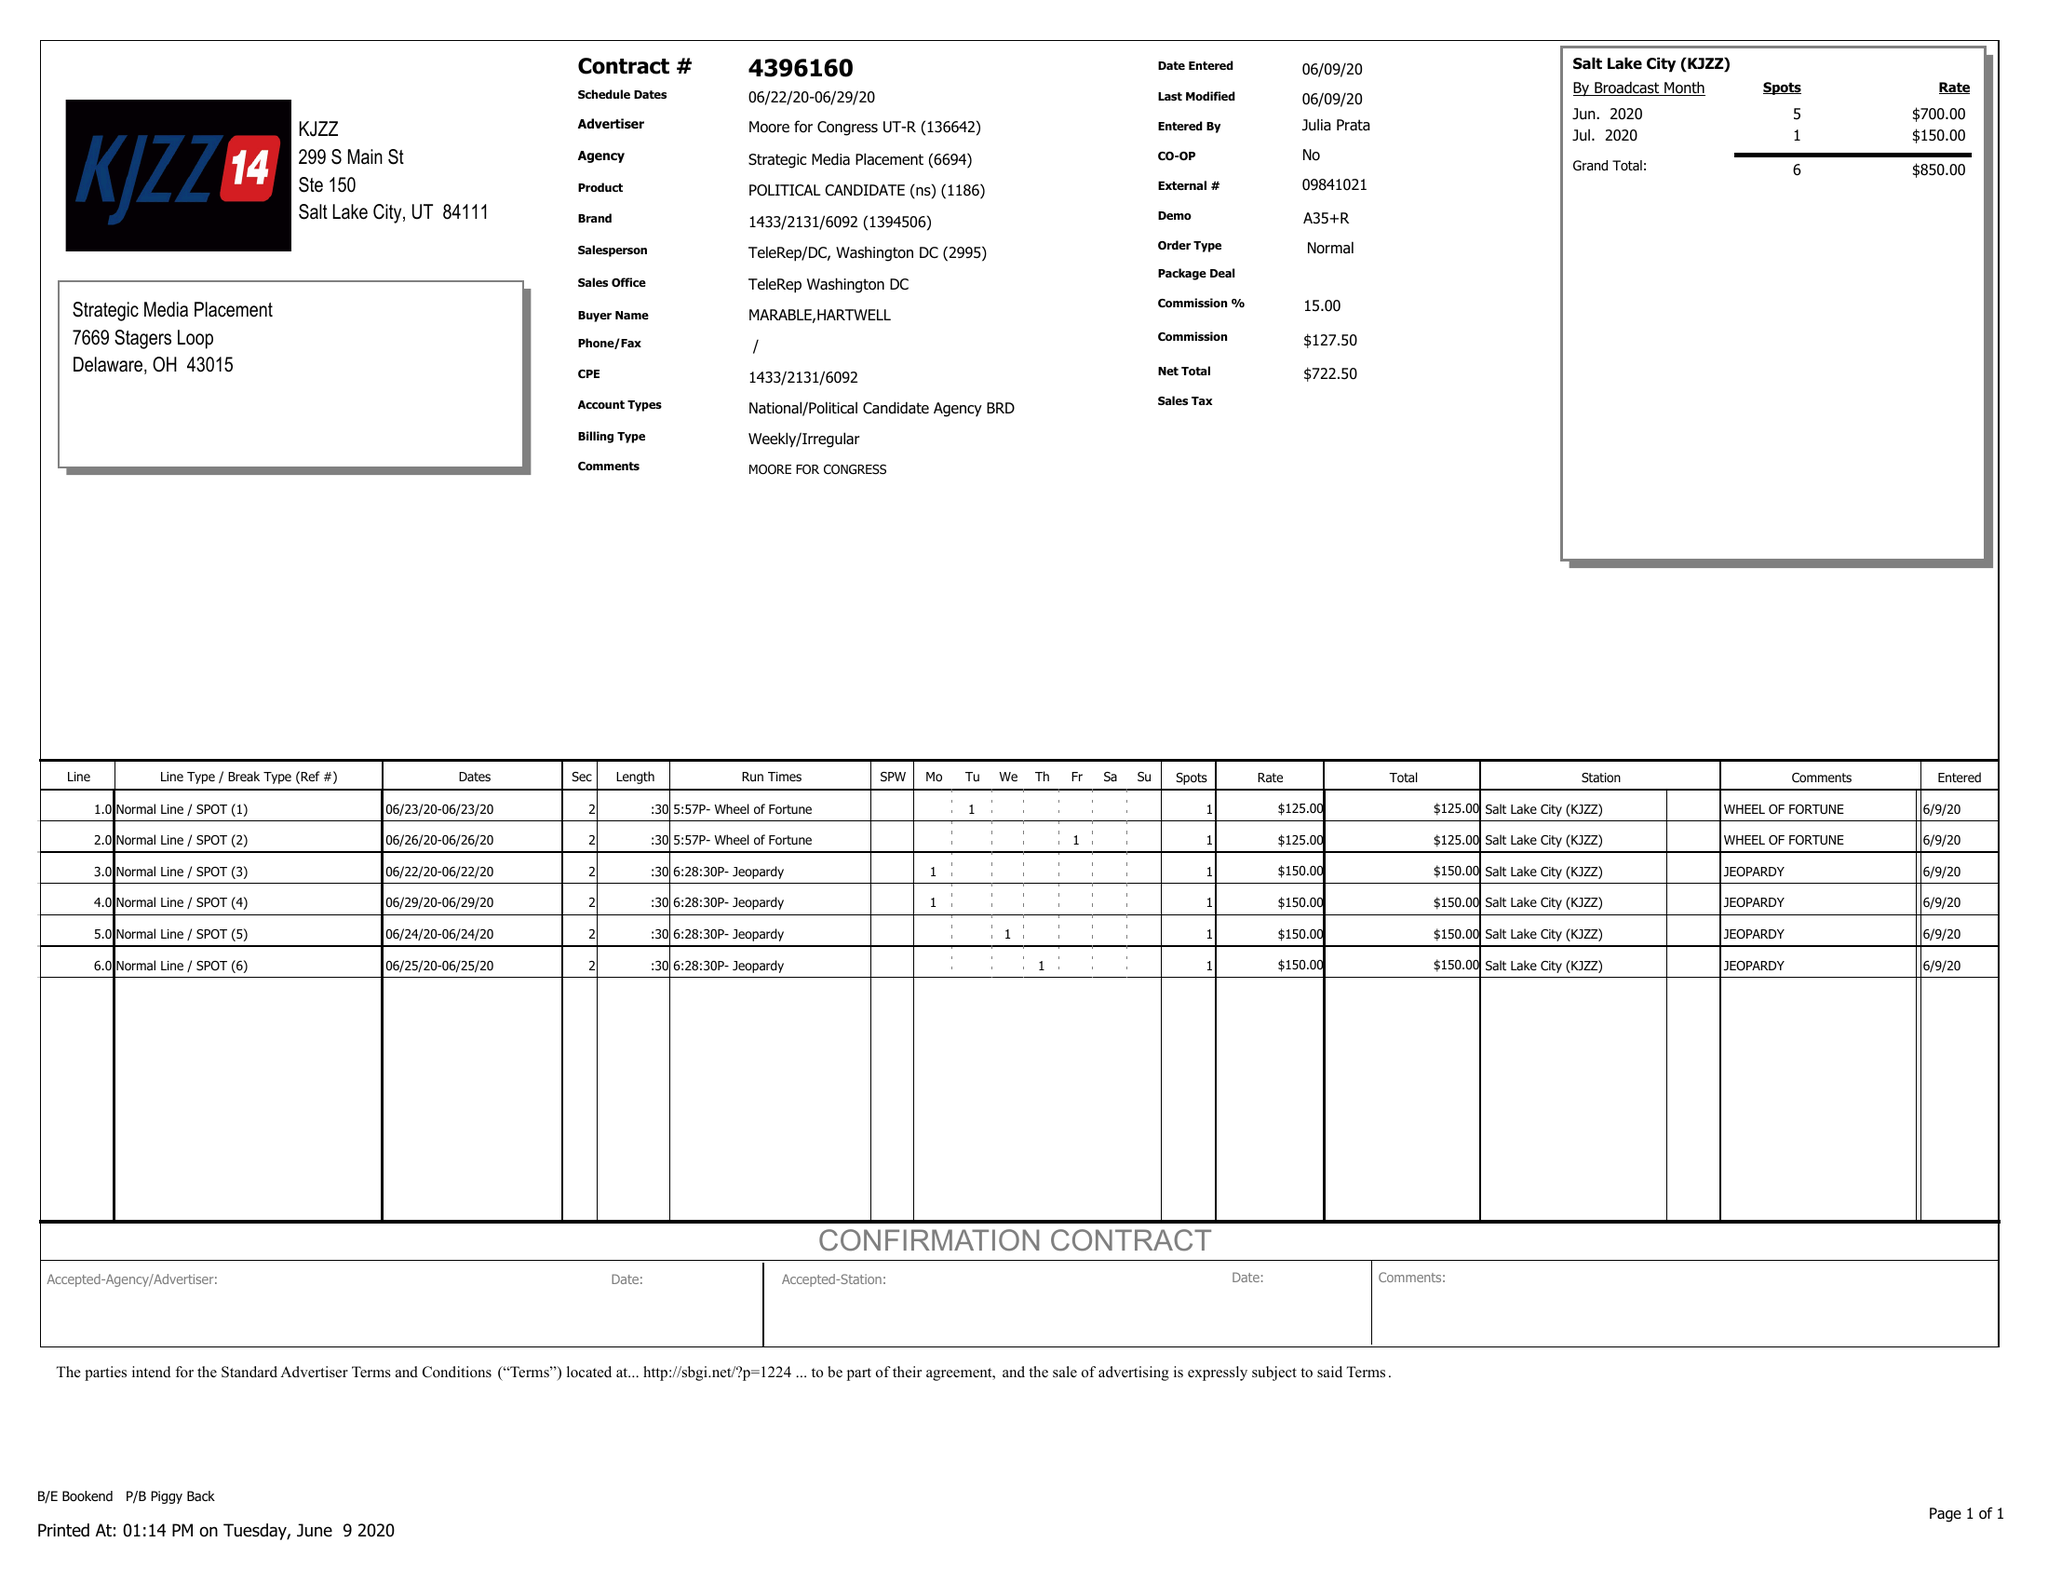What is the value for the contract_num?
Answer the question using a single word or phrase. 4396160 